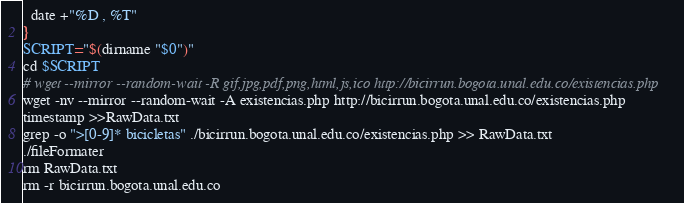<code> <loc_0><loc_0><loc_500><loc_500><_Bash_>  date +"%D , %T"
}
SCRIPT="$(dirname "$0")"
cd $SCRIPT
# wget --mirror --random-wait -R gif,jpg,pdf,png,html,js,ico http://bicirrun.bogota.unal.edu.co/existencias.php
wget -nv --mirror --random-wait -A existencias.php http://bicirrun.bogota.unal.edu.co/existencias.php
timestamp >>RawData.txt
grep -o ">[0-9]* bicicletas" ./bicirrun.bogota.unal.edu.co/existencias.php >> RawData.txt
./fileFormater
rm RawData.txt
rm -r bicirrun.bogota.unal.edu.co</code> 